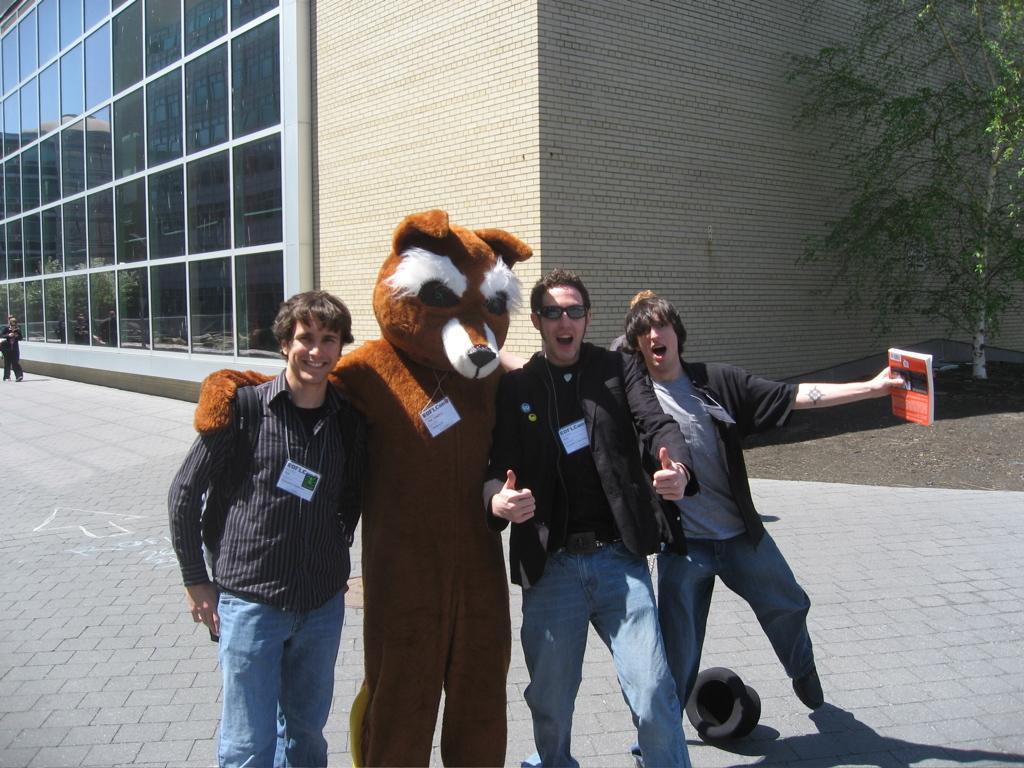Can you describe this image briefly? In this image I see 3 men and I see that there is a person who is wearing a costume of an animal and the costume is of brown and white in color and I see that these 3 men are smiling and I see that this man is holding a book and I see the path. In the background I see the building, a person over here and I see the tree over here and I see a thing over here. 